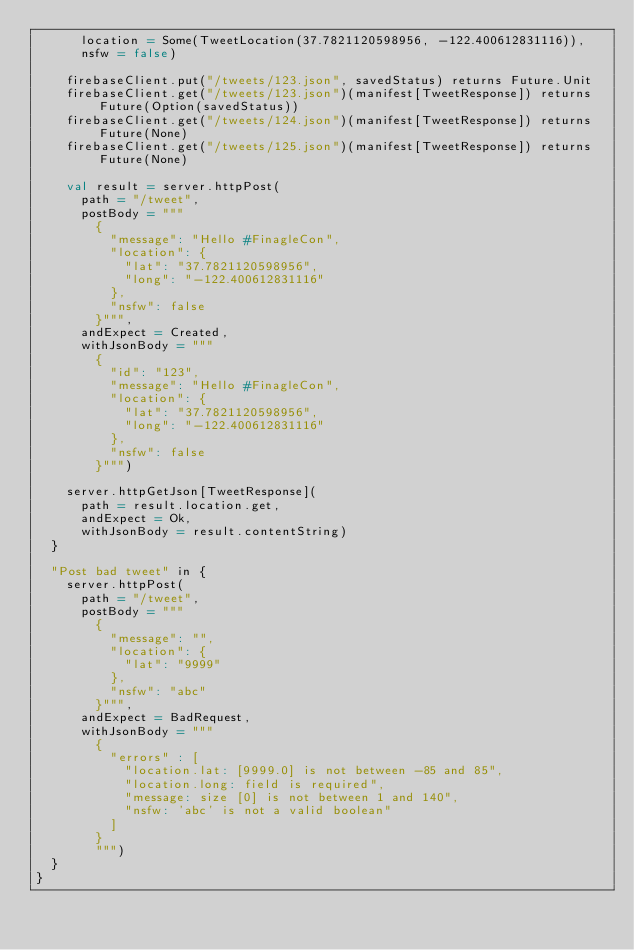<code> <loc_0><loc_0><loc_500><loc_500><_Scala_>      location = Some(TweetLocation(37.7821120598956, -122.400612831116)),
      nsfw = false)

    firebaseClient.put("/tweets/123.json", savedStatus) returns Future.Unit
    firebaseClient.get("/tweets/123.json")(manifest[TweetResponse]) returns Future(Option(savedStatus))
    firebaseClient.get("/tweets/124.json")(manifest[TweetResponse]) returns Future(None)
    firebaseClient.get("/tweets/125.json")(manifest[TweetResponse]) returns Future(None)

    val result = server.httpPost(
      path = "/tweet",
      postBody = """
        {
          "message": "Hello #FinagleCon",
          "location": {
            "lat": "37.7821120598956",
            "long": "-122.400612831116"
          },
          "nsfw": false
        }""",
      andExpect = Created,
      withJsonBody = """
        {
          "id": "123",
          "message": "Hello #FinagleCon",
          "location": {
            "lat": "37.7821120598956",
            "long": "-122.400612831116"
          },
          "nsfw": false
        }""")

    server.httpGetJson[TweetResponse](
      path = result.location.get,
      andExpect = Ok,
      withJsonBody = result.contentString)
  }

  "Post bad tweet" in {
    server.httpPost(
      path = "/tweet",
      postBody = """
        {
          "message": "",
          "location": {
            "lat": "9999"
          },
          "nsfw": "abc"
        }""",
      andExpect = BadRequest,
      withJsonBody = """
        {
          "errors" : [
            "location.lat: [9999.0] is not between -85 and 85",
            "location.long: field is required",
            "message: size [0] is not between 1 and 140",
            "nsfw: 'abc' is not a valid boolean"
          ]
        }
        """)
  }
}
</code> 